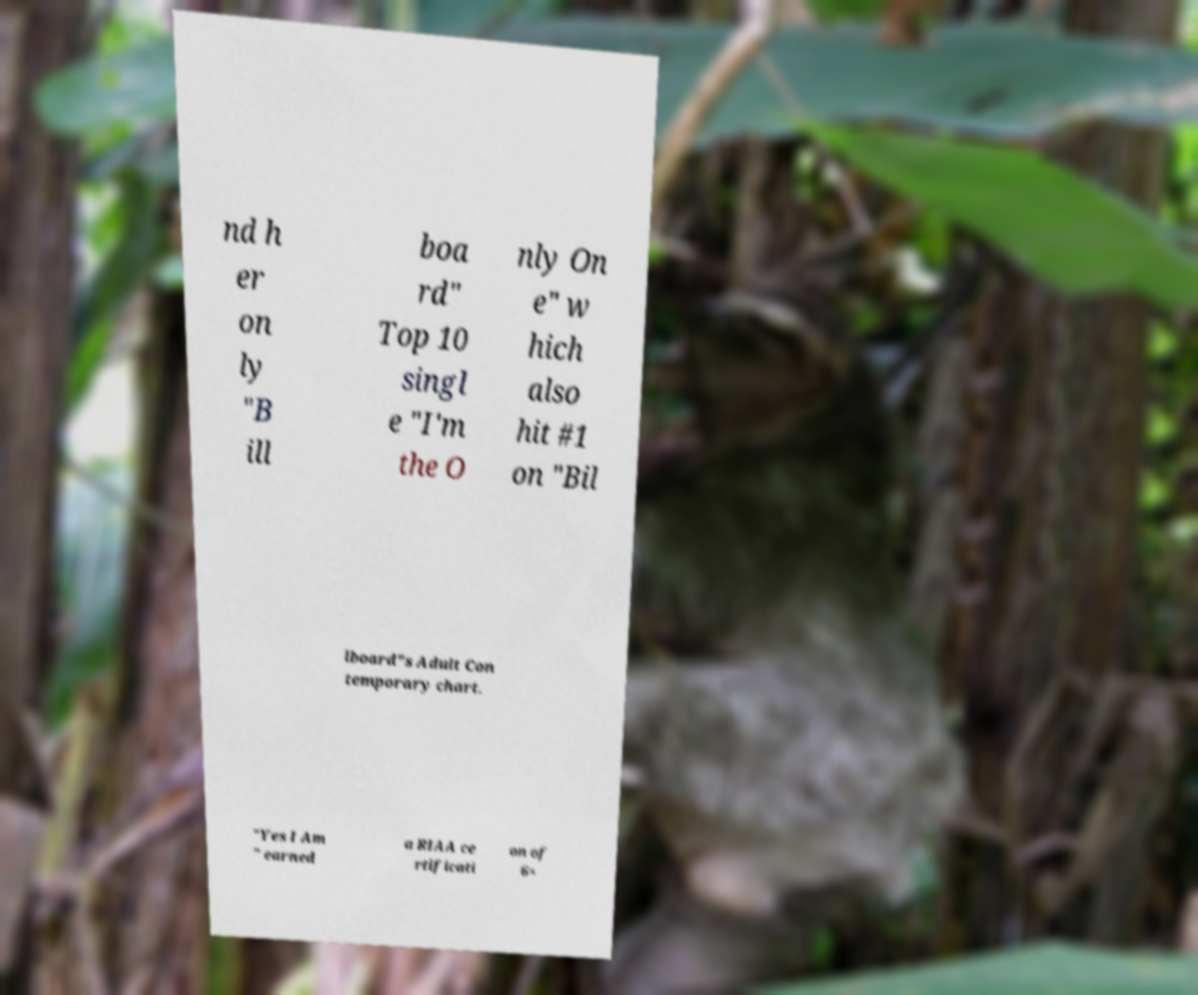Please identify and transcribe the text found in this image. nd h er on ly "B ill boa rd" Top 10 singl e "I'm the O nly On e" w hich also hit #1 on "Bil lboard"s Adult Con temporary chart. "Yes I Am " earned a RIAA ce rtificati on of 6× 